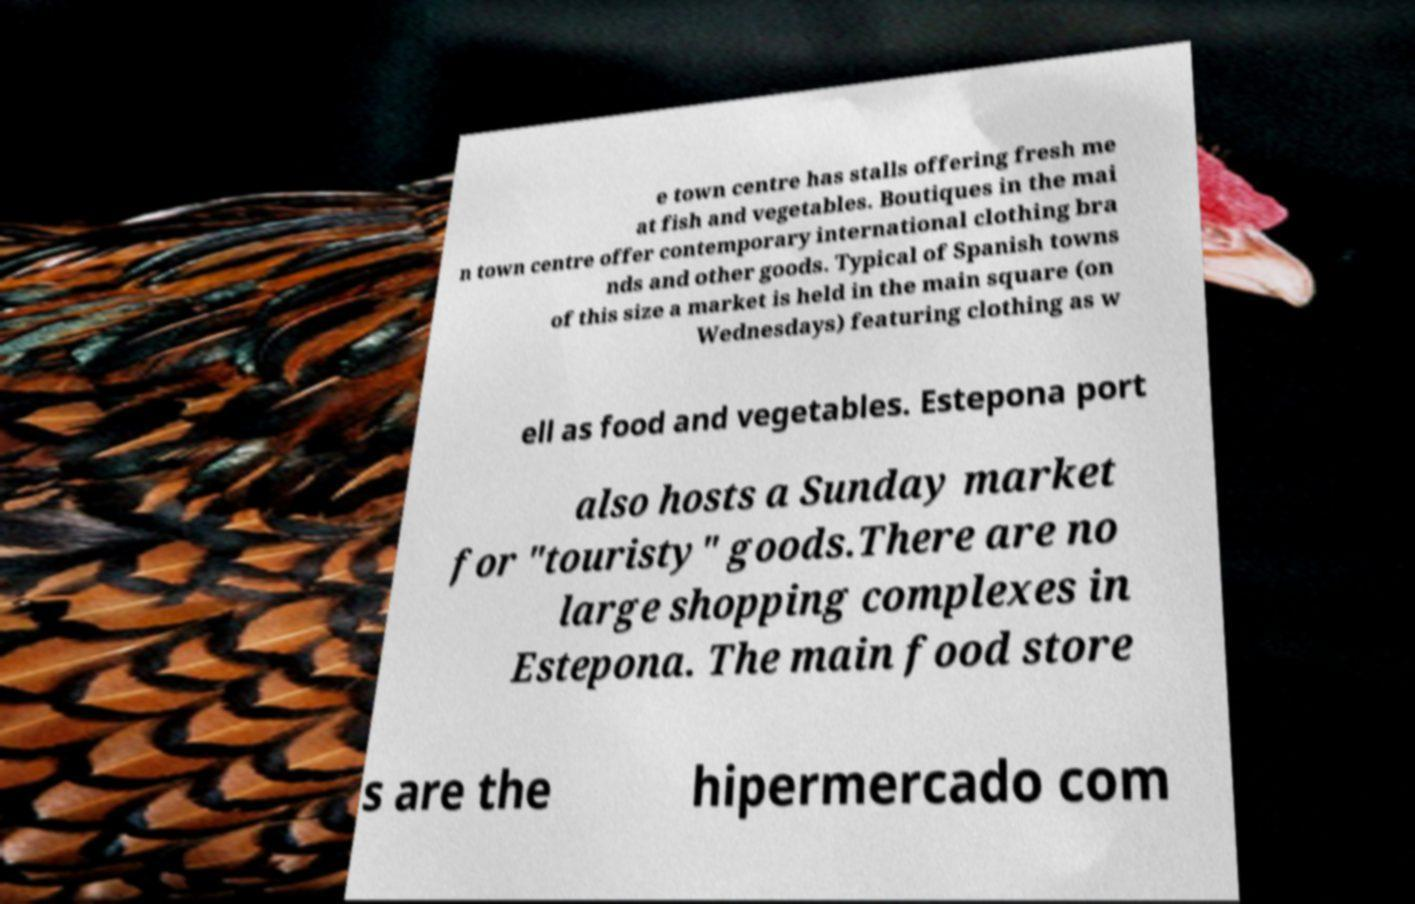Can you accurately transcribe the text from the provided image for me? e town centre has stalls offering fresh me at fish and vegetables. Boutiques in the mai n town centre offer contemporary international clothing bra nds and other goods. Typical of Spanish towns of this size a market is held in the main square (on Wednesdays) featuring clothing as w ell as food and vegetables. Estepona port also hosts a Sunday market for "touristy" goods.There are no large shopping complexes in Estepona. The main food store s are the hipermercado com 